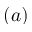<formula> <loc_0><loc_0><loc_500><loc_500>( a )</formula> 